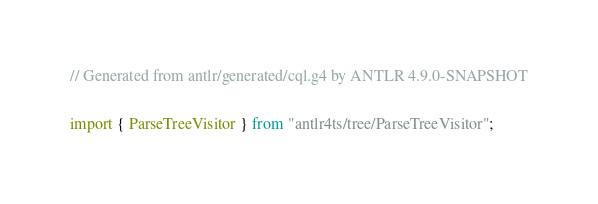<code> <loc_0><loc_0><loc_500><loc_500><_TypeScript_>// Generated from antlr/generated/cql.g4 by ANTLR 4.9.0-SNAPSHOT


import { ParseTreeVisitor } from "antlr4ts/tree/ParseTreeVisitor";
</code> 